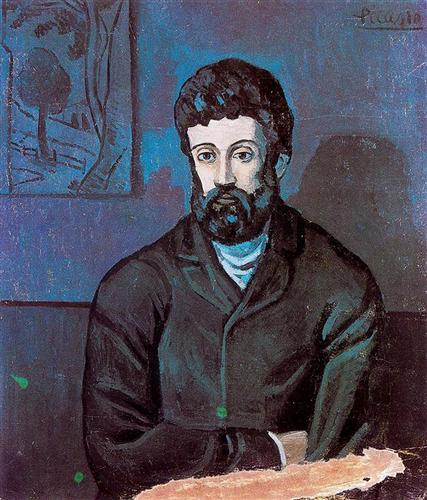What can you infer about the subject's mood based on his expression and posture? The subject’s expression is pensive and somewhat introspective. His slightly furrowed brows and the direct gaze imply a contemplative, perhaps melancholic mood. His posture, upright yet relaxed, and the hands gently resting on the table, also reinforce a feeling of quiet reflection. The choice of darker clothing and the subdued background colors further accentuate the reflective and serious tone of the portrait. 